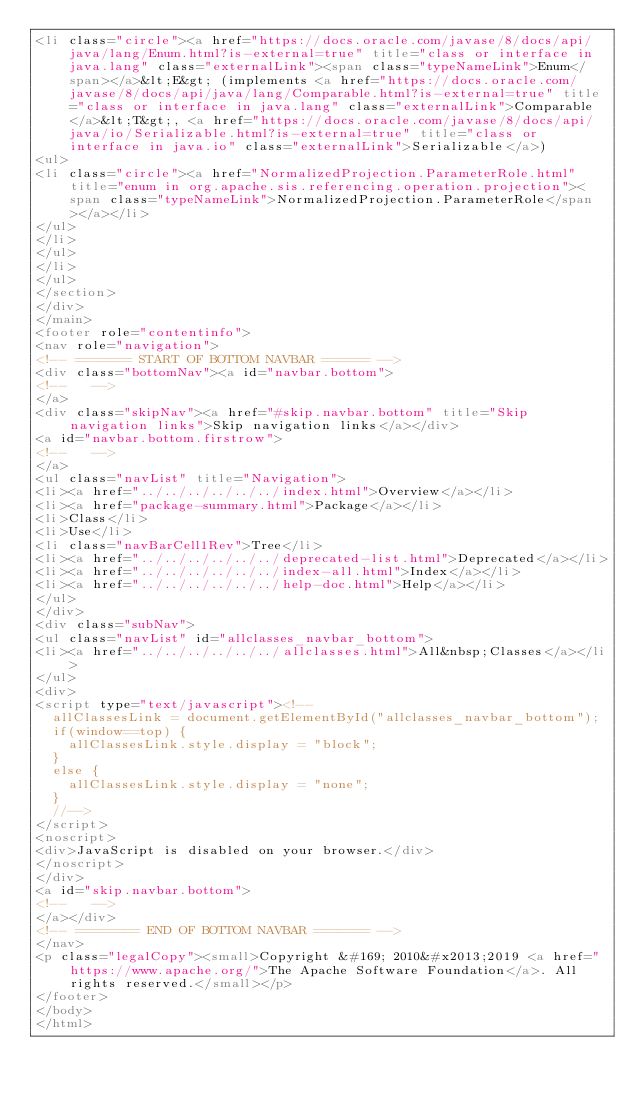Convert code to text. <code><loc_0><loc_0><loc_500><loc_500><_HTML_><li class="circle"><a href="https://docs.oracle.com/javase/8/docs/api/java/lang/Enum.html?is-external=true" title="class or interface in java.lang" class="externalLink"><span class="typeNameLink">Enum</span></a>&lt;E&gt; (implements <a href="https://docs.oracle.com/javase/8/docs/api/java/lang/Comparable.html?is-external=true" title="class or interface in java.lang" class="externalLink">Comparable</a>&lt;T&gt;, <a href="https://docs.oracle.com/javase/8/docs/api/java/io/Serializable.html?is-external=true" title="class or interface in java.io" class="externalLink">Serializable</a>)
<ul>
<li class="circle"><a href="NormalizedProjection.ParameterRole.html" title="enum in org.apache.sis.referencing.operation.projection"><span class="typeNameLink">NormalizedProjection.ParameterRole</span></a></li>
</ul>
</li>
</ul>
</li>
</ul>
</section>
</div>
</main>
<footer role="contentinfo">
<nav role="navigation">
<!-- ======= START OF BOTTOM NAVBAR ====== -->
<div class="bottomNav"><a id="navbar.bottom">
<!--   -->
</a>
<div class="skipNav"><a href="#skip.navbar.bottom" title="Skip navigation links">Skip navigation links</a></div>
<a id="navbar.bottom.firstrow">
<!--   -->
</a>
<ul class="navList" title="Navigation">
<li><a href="../../../../../../index.html">Overview</a></li>
<li><a href="package-summary.html">Package</a></li>
<li>Class</li>
<li>Use</li>
<li class="navBarCell1Rev">Tree</li>
<li><a href="../../../../../../deprecated-list.html">Deprecated</a></li>
<li><a href="../../../../../../index-all.html">Index</a></li>
<li><a href="../../../../../../help-doc.html">Help</a></li>
</ul>
</div>
<div class="subNav">
<ul class="navList" id="allclasses_navbar_bottom">
<li><a href="../../../../../../allclasses.html">All&nbsp;Classes</a></li>
</ul>
<div>
<script type="text/javascript"><!--
  allClassesLink = document.getElementById("allclasses_navbar_bottom");
  if(window==top) {
    allClassesLink.style.display = "block";
  }
  else {
    allClassesLink.style.display = "none";
  }
  //-->
</script>
<noscript>
<div>JavaScript is disabled on your browser.</div>
</noscript>
</div>
<a id="skip.navbar.bottom">
<!--   -->
</a></div>
<!-- ======== END OF BOTTOM NAVBAR ======= -->
</nav>
<p class="legalCopy"><small>Copyright &#169; 2010&#x2013;2019 <a href="https://www.apache.org/">The Apache Software Foundation</a>. All rights reserved.</small></p>
</footer>
</body>
</html>
</code> 